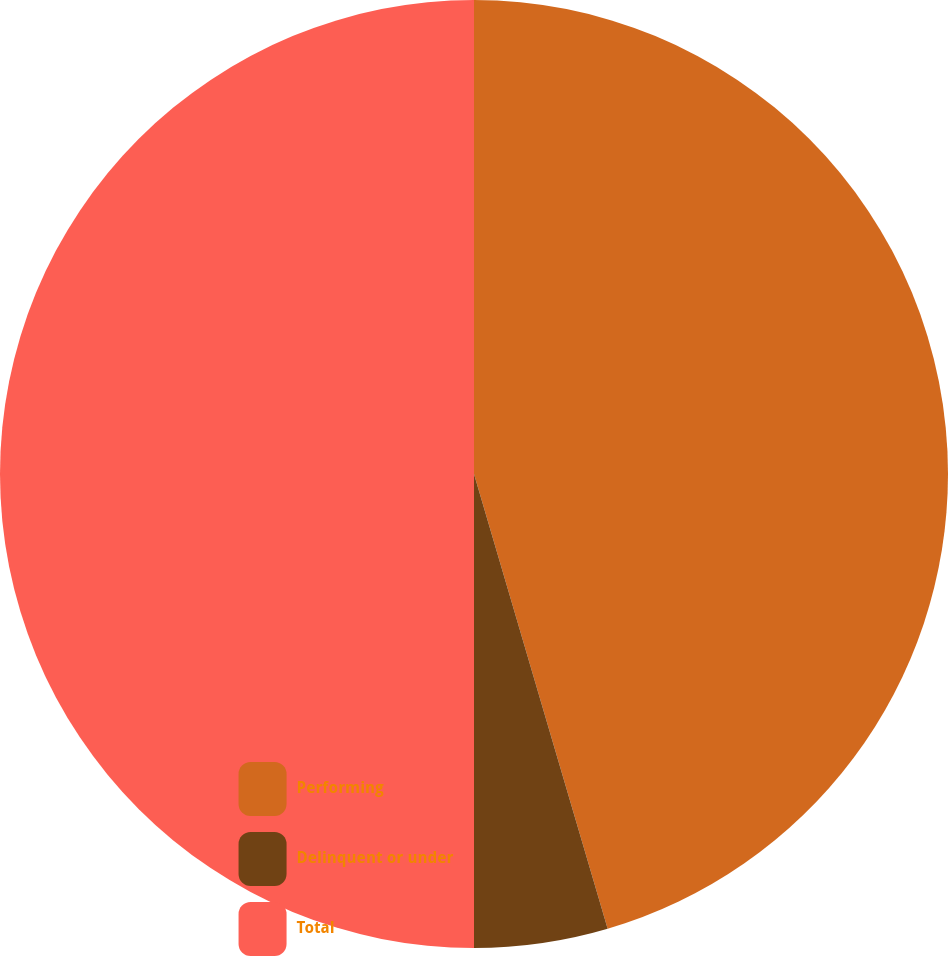Convert chart. <chart><loc_0><loc_0><loc_500><loc_500><pie_chart><fcel>Performing<fcel>Delinquent or under<fcel>Total<nl><fcel>45.45%<fcel>4.55%<fcel>50.0%<nl></chart> 